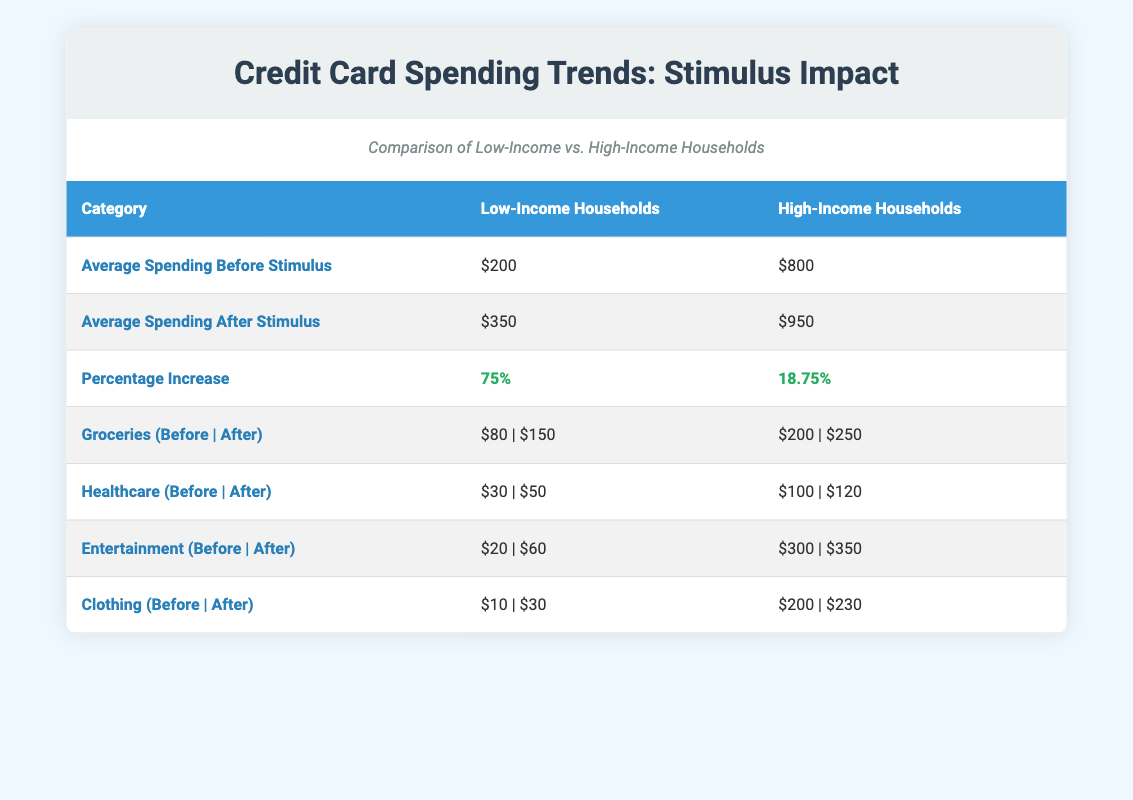What is the average credit card spending of low-income households before the stimulus? According to the table, the average credit card spending before the stimulus check for low-income households is listed as $200.
Answer: 200 What is the percentage increase in credit card spending for high-income households after receiving the stimulus checks? The table shows that the percentage increase in credit card spending for high-income households is 18.75%.
Answer: 18.75% How much did low-income households spend on entertainment before the stimulus check? The table indicates that low-income households spent $20 on entertainment before the stimulus check.
Answer: 20 What is the difference in average credit card spending after the stimulus checks between low-income and high-income households? The average spending after for low-income households is $350, and for high-income households, it is $950. The difference is calculated as 950 - 350 = 600.
Answer: 600 Did healthcare spending increase for both low-income and high-income households after the stimulus? Yes, the table shows that healthcare spending increased from $30 to $50 for low-income households and from $100 to $120 for high-income households.
Answer: Yes What was the total average spending on groceries for low-income households before and after the stimulus check? The average spending on groceries for low-income households before the stimulus was $80 and after it was $150. Adding these values gives 80 + 150 = 230.
Answer: 230 Which spending category saw the largest increase for low-income households? In the table, the entertainment category had the largest increase, going from $20 before to $60 after the stimulus, which is an increase of $40.
Answer: Entertainment What was the average credit card spending for high-income households before the stimulus? The table provides that the average credit card spending for high-income households before the stimulus check was $800.
Answer: 800 How much did clothing spending change in low-income households after the stimulus? Low-income households spent $10 on clothing before the stimulus, and after it, the spending rose to $30. The change in spending is 30 - 10 = 20.
Answer: 20 